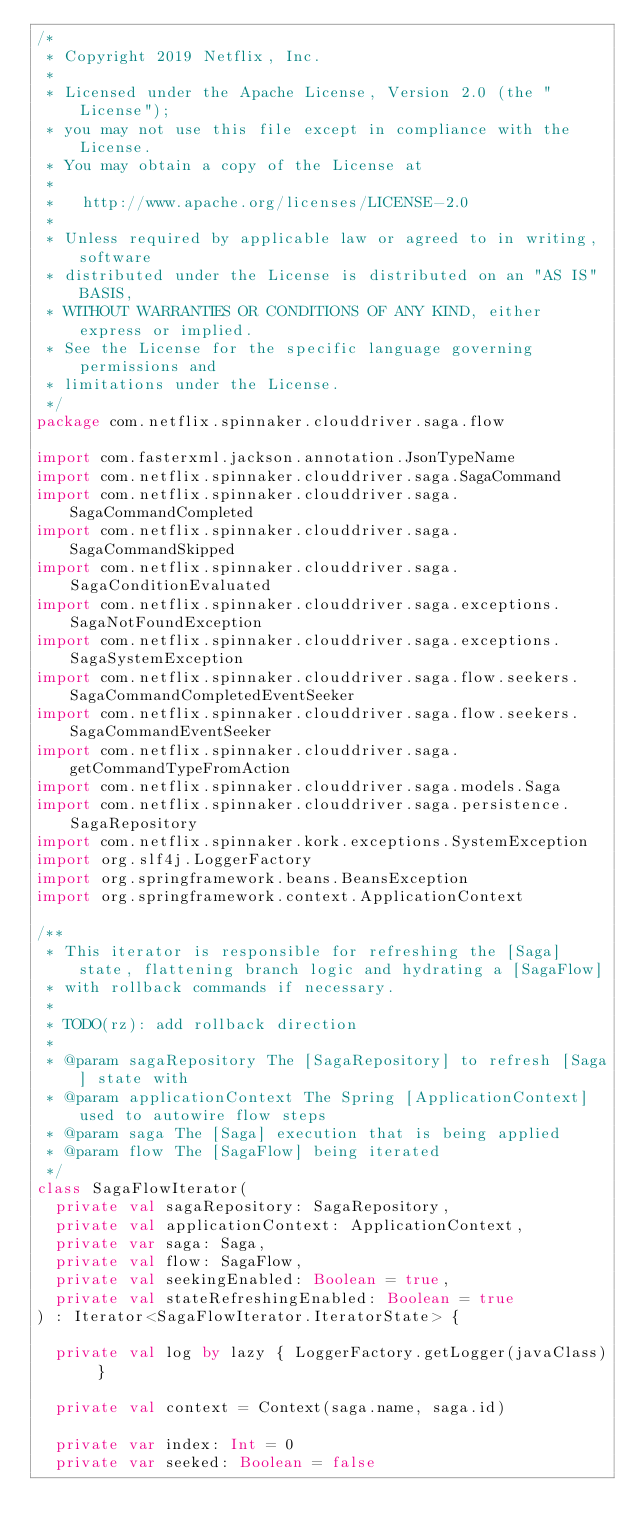Convert code to text. <code><loc_0><loc_0><loc_500><loc_500><_Kotlin_>/*
 * Copyright 2019 Netflix, Inc.
 *
 * Licensed under the Apache License, Version 2.0 (the "License");
 * you may not use this file except in compliance with the License.
 * You may obtain a copy of the License at
 *
 *   http://www.apache.org/licenses/LICENSE-2.0
 *
 * Unless required by applicable law or agreed to in writing, software
 * distributed under the License is distributed on an "AS IS" BASIS,
 * WITHOUT WARRANTIES OR CONDITIONS OF ANY KIND, either express or implied.
 * See the License for the specific language governing permissions and
 * limitations under the License.
 */
package com.netflix.spinnaker.clouddriver.saga.flow

import com.fasterxml.jackson.annotation.JsonTypeName
import com.netflix.spinnaker.clouddriver.saga.SagaCommand
import com.netflix.spinnaker.clouddriver.saga.SagaCommandCompleted
import com.netflix.spinnaker.clouddriver.saga.SagaCommandSkipped
import com.netflix.spinnaker.clouddriver.saga.SagaConditionEvaluated
import com.netflix.spinnaker.clouddriver.saga.exceptions.SagaNotFoundException
import com.netflix.spinnaker.clouddriver.saga.exceptions.SagaSystemException
import com.netflix.spinnaker.clouddriver.saga.flow.seekers.SagaCommandCompletedEventSeeker
import com.netflix.spinnaker.clouddriver.saga.flow.seekers.SagaCommandEventSeeker
import com.netflix.spinnaker.clouddriver.saga.getCommandTypeFromAction
import com.netflix.spinnaker.clouddriver.saga.models.Saga
import com.netflix.spinnaker.clouddriver.saga.persistence.SagaRepository
import com.netflix.spinnaker.kork.exceptions.SystemException
import org.slf4j.LoggerFactory
import org.springframework.beans.BeansException
import org.springframework.context.ApplicationContext

/**
 * This iterator is responsible for refreshing the [Saga] state, flattening branch logic and hydrating a [SagaFlow]
 * with rollback commands if necessary.
 *
 * TODO(rz): add rollback direction
 *
 * @param sagaRepository The [SagaRepository] to refresh [Saga] state with
 * @param applicationContext The Spring [ApplicationContext] used to autowire flow steps
 * @param saga The [Saga] execution that is being applied
 * @param flow The [SagaFlow] being iterated
 */
class SagaFlowIterator(
  private val sagaRepository: SagaRepository,
  private val applicationContext: ApplicationContext,
  private var saga: Saga,
  private val flow: SagaFlow,
  private val seekingEnabled: Boolean = true,
  private val stateRefreshingEnabled: Boolean = true
) : Iterator<SagaFlowIterator.IteratorState> {

  private val log by lazy { LoggerFactory.getLogger(javaClass) }

  private val context = Context(saga.name, saga.id)

  private var index: Int = 0
  private var seeked: Boolean = false
</code> 